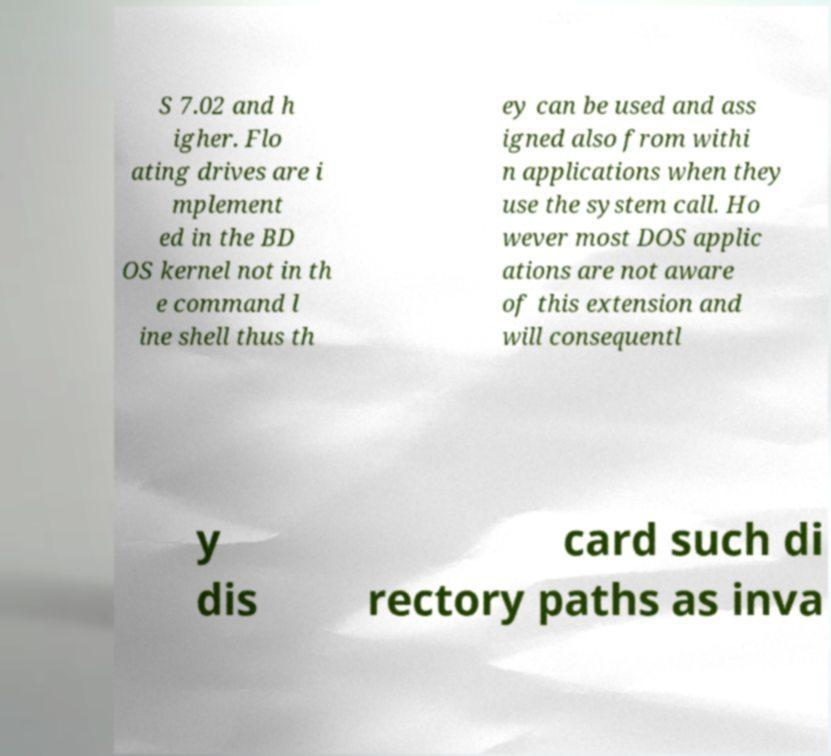What messages or text are displayed in this image? I need them in a readable, typed format. S 7.02 and h igher. Flo ating drives are i mplement ed in the BD OS kernel not in th e command l ine shell thus th ey can be used and ass igned also from withi n applications when they use the system call. Ho wever most DOS applic ations are not aware of this extension and will consequentl y dis card such di rectory paths as inva 